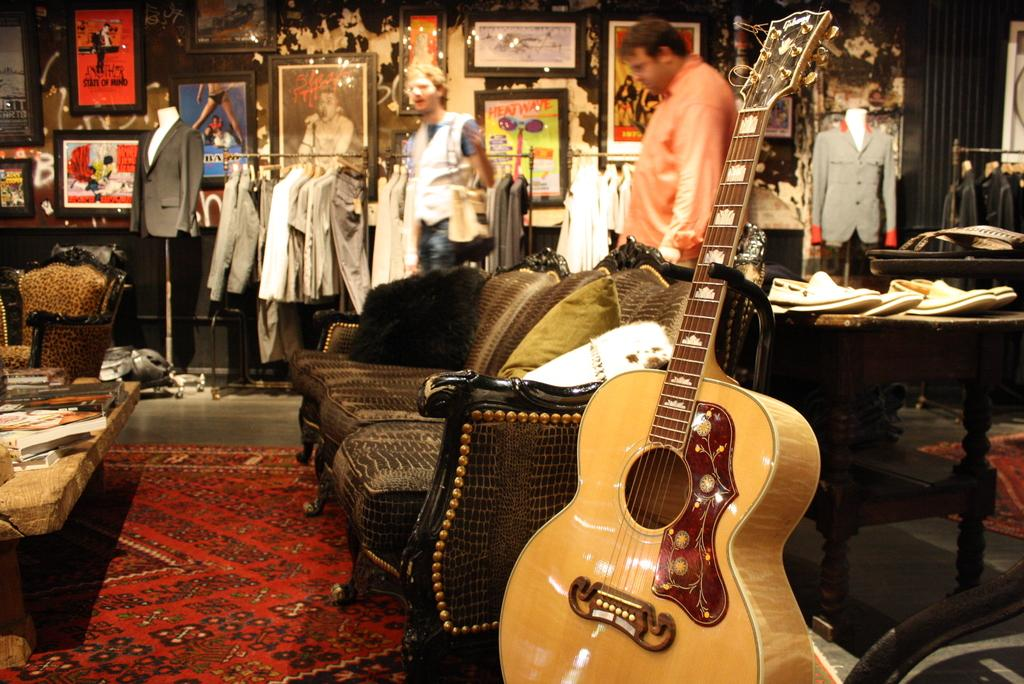What type of furniture is in the image? There is a brown sofa in the image. What object is placed beside the sofa? A guitar is beside the sofa. What type of clothing is on the other side of the sofa? There are dresses on the other side of the sofa. How many people are visible behind the sofa? There are two persons behind the sofa. What type of slope can be seen in the image? There is no slope present in the image. How does the wind affect the guitar in the image? The image does not show any wind, and the guitar is not affected by it. 